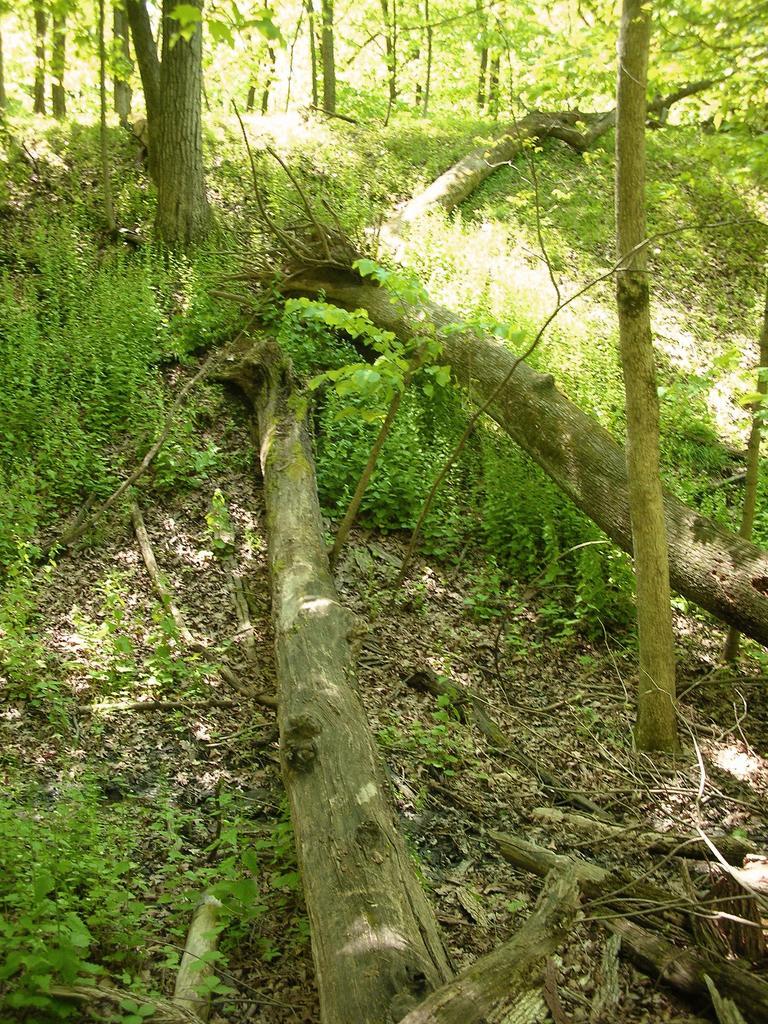Could you give a brief overview of what you see in this image? In this image we can see some bark of the trees fell down on the trees. We can also see some trees, plants and the dried leaves on the land. 